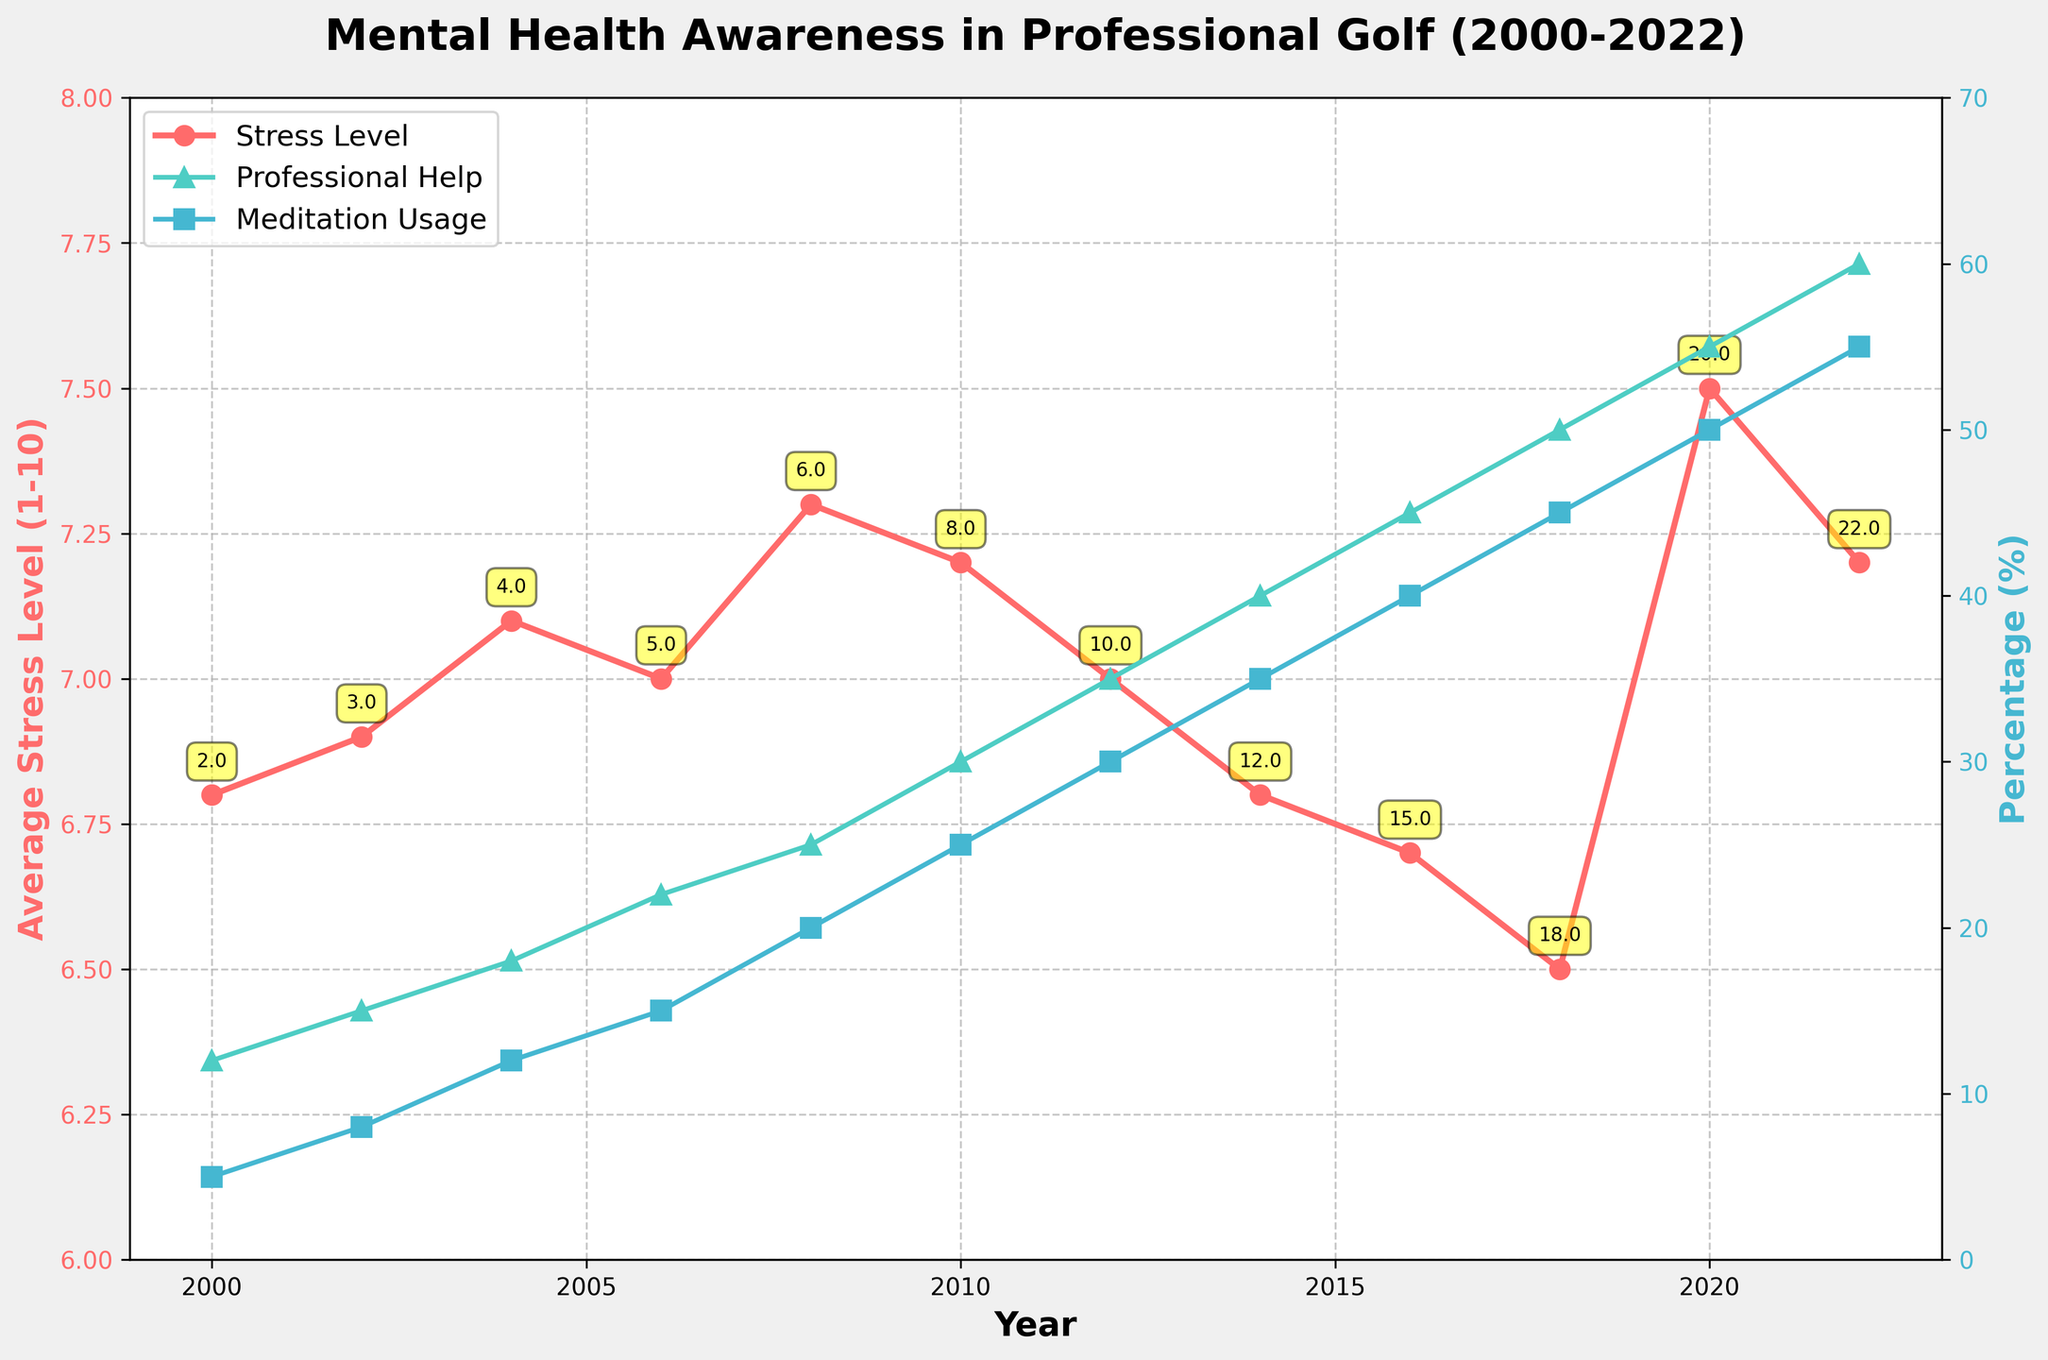What year had the highest average stress level and what was the value? To determine the highest average stress level, locate the peak point on the "Average Stress Level" line. The highest point is in the year 2020, with a value of 7.5
Answer: 2020, 7.5 Which year had the greatest percentage of players seeking professional help and what was the percentage? Identify the highest point on the "Players Seeking Professional Help" line. The peak is in the year 2022, with 60% of players seeking professional help.
Answer: 2022, 60% Compare the percentage of players using meditation in 2002 and 2020. Which year had a higher percentage and by how much? Find the data points for meditation usage in 2002 (8%) and 2020 (50%). Subtract the 2002 value from the 2020 value to find the difference. 50% - 8% = 42%. 2020 had a higher percentage by 42%.
Answer: 2020, by 42% What is the trend in the number of mental health programs offered from 2000 to 2022? Examine the annotations for mental health programs offered over the years. Starting from 2 in 2000 and gradually increasing to 22 in 2022, there is an upward trend.
Answer: Increasing How did the average stress level change from 2000 to 2018? Look at the line for average stress levels from 2000 to 2018. In 2000, it started at 6.8 and, by 2018, it decreased to 6.5, showing a slight downward trend.
Answer: Decreased By what amount did the percentage of players seeking professional help increase from 2008 to 2022? Determine the percentage values for 2008 (25%) and 2022 (60%), and then calculate the difference. 60% - 25% = 35%.
Answer: Increased by 35% Which year had the lowest average stress level and what initiatives were in place that year? Find the lowest point on the "Average Stress Level" line, which is in 2018 with a value of 6.5. In that year, there were 18 mental health programs offered, and 7 PGA Tour Mental Health Initiatives.
Answer: 2018, 18 programs, 7 initiatives How does the trend in meditation usage compare to the trend in players seeking professional help? Compare the trends of the two lines. Both lines show upward trends, but meditation usage starts lower and ends lower than the percentage of players seeking professional help.
Answer: Both increasing What specific value annotations are consistently present along the stress level line? The annotations along the stress level line consistently show the number of mental health programs offered for each year.
Answer: Number of mental health programs 